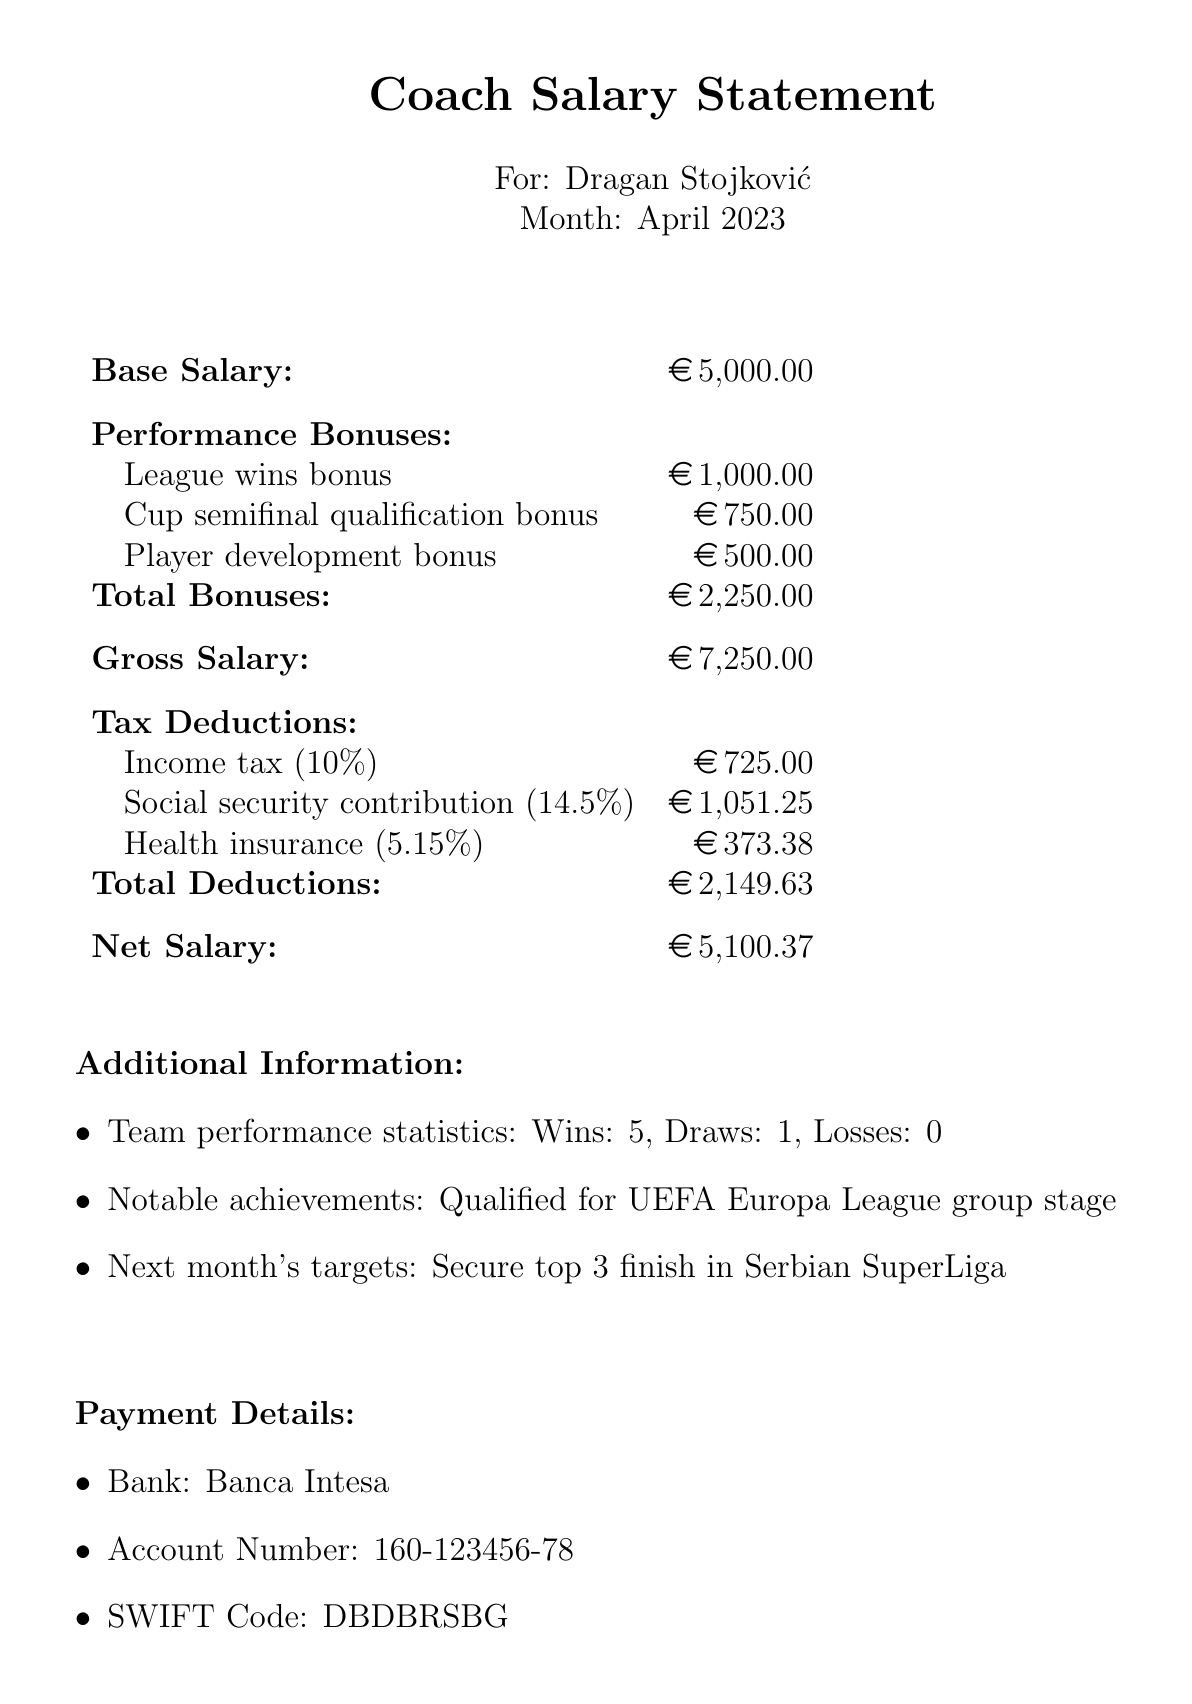What is the coach's name? The coach's name is explicitly stated in the document as part of the heading.
Answer: Dragan Stojković What is the base salary? The base salary is prominently listed as a fixed amount in the salary breakdown section of the document.
Answer: 5000 EUR What are the total bonuses? The total bonuses are the sum of all performance bonuses listed in the document.
Answer: 2250 EUR What is the date of approval? The approval date can be found in the signature section of the document.
Answer: 2023-05-05 What is the net salary? The net salary is mentioned clearly in the salary breakdown, showing the final amount after deductions.
Answer: 5100.37 EUR How much is deducted for social security contribution? The document lists the amount deducted specifically for social security under the tax deductions section.
Answer: 1051.25 EUR What notable achievement is mentioned? The document highlights a specific achievement that reflects the team's success in competitions, indicating high performance.
Answer: Qualified for UEFA Europa League group stage What is next month's target? The document outlines a goal for the upcoming month that the coach and team aim to achieve.
Answer: Secure top 3 finish in Serbian SuperLiga 